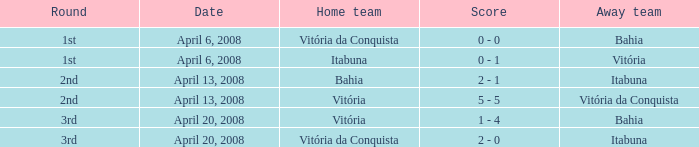On which date was the score 0 - 0? April 6, 2008. 